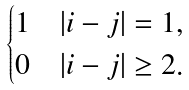Convert formula to latex. <formula><loc_0><loc_0><loc_500><loc_500>\begin{cases} 1 & | i - j | = 1 , \\ 0 & | i - j | \geq 2 . \end{cases}</formula> 